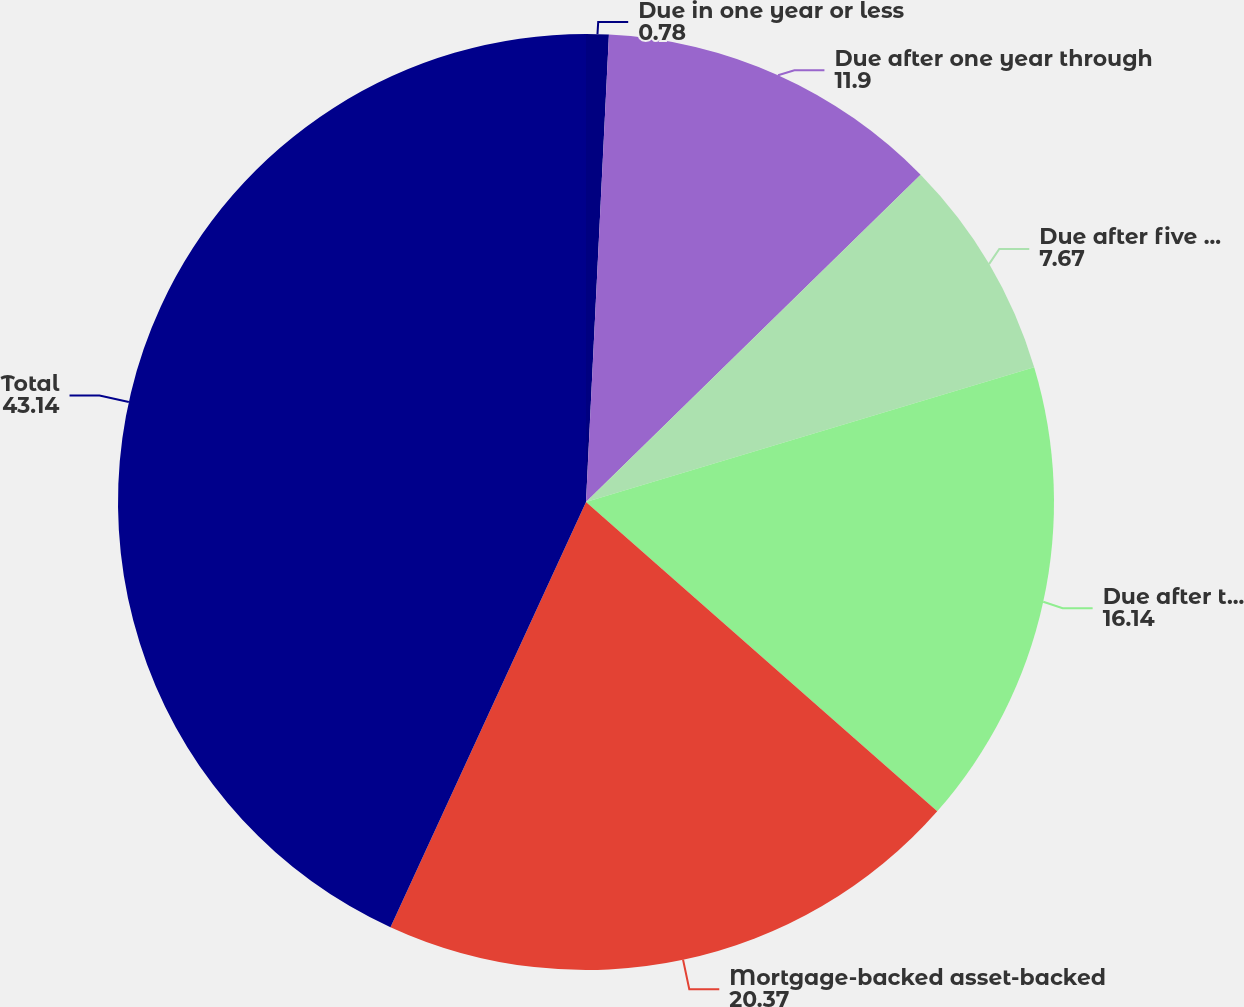Convert chart. <chart><loc_0><loc_0><loc_500><loc_500><pie_chart><fcel>Due in one year or less<fcel>Due after one year through<fcel>Due after five years through<fcel>Due after ten years<fcel>Mortgage-backed asset-backed<fcel>Total<nl><fcel>0.78%<fcel>11.9%<fcel>7.67%<fcel>16.14%<fcel>20.37%<fcel>43.14%<nl></chart> 